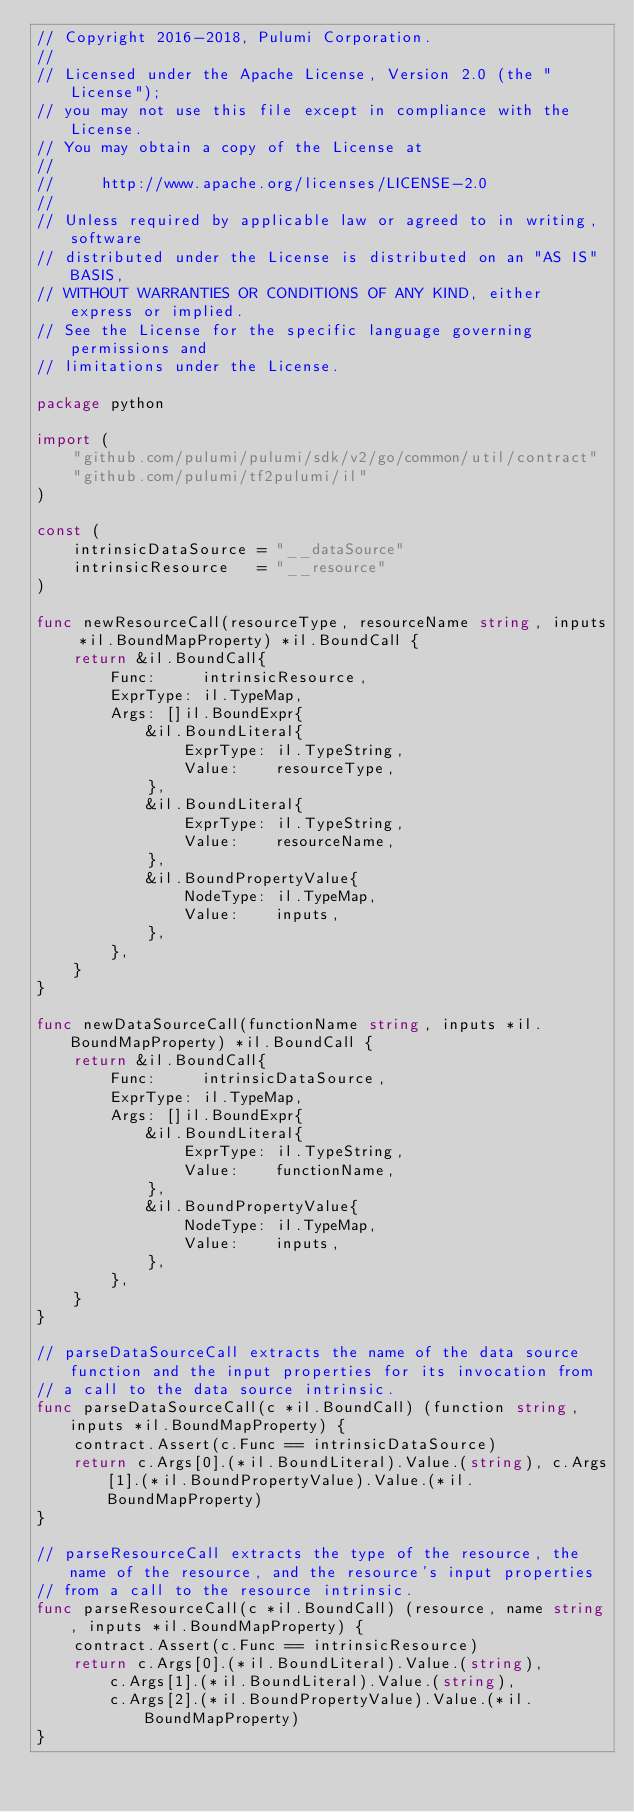Convert code to text. <code><loc_0><loc_0><loc_500><loc_500><_Go_>// Copyright 2016-2018, Pulumi Corporation.
//
// Licensed under the Apache License, Version 2.0 (the "License");
// you may not use this file except in compliance with the License.
// You may obtain a copy of the License at
//
//     http://www.apache.org/licenses/LICENSE-2.0
//
// Unless required by applicable law or agreed to in writing, software
// distributed under the License is distributed on an "AS IS" BASIS,
// WITHOUT WARRANTIES OR CONDITIONS OF ANY KIND, either express or implied.
// See the License for the specific language governing permissions and
// limitations under the License.

package python

import (
	"github.com/pulumi/pulumi/sdk/v2/go/common/util/contract"
	"github.com/pulumi/tf2pulumi/il"
)

const (
	intrinsicDataSource = "__dataSource"
	intrinsicResource   = "__resource"
)

func newResourceCall(resourceType, resourceName string, inputs *il.BoundMapProperty) *il.BoundCall {
	return &il.BoundCall{
		Func:     intrinsicResource,
		ExprType: il.TypeMap,
		Args: []il.BoundExpr{
			&il.BoundLiteral{
				ExprType: il.TypeString,
				Value:    resourceType,
			},
			&il.BoundLiteral{
				ExprType: il.TypeString,
				Value:    resourceName,
			},
			&il.BoundPropertyValue{
				NodeType: il.TypeMap,
				Value:    inputs,
			},
		},
	}
}

func newDataSourceCall(functionName string, inputs *il.BoundMapProperty) *il.BoundCall {
	return &il.BoundCall{
		Func:     intrinsicDataSource,
		ExprType: il.TypeMap,
		Args: []il.BoundExpr{
			&il.BoundLiteral{
				ExprType: il.TypeString,
				Value:    functionName,
			},
			&il.BoundPropertyValue{
				NodeType: il.TypeMap,
				Value:    inputs,
			},
		},
	}
}

// parseDataSourceCall extracts the name of the data source function and the input properties for its invocation from
// a call to the data source intrinsic.
func parseDataSourceCall(c *il.BoundCall) (function string, inputs *il.BoundMapProperty) {
	contract.Assert(c.Func == intrinsicDataSource)
	return c.Args[0].(*il.BoundLiteral).Value.(string), c.Args[1].(*il.BoundPropertyValue).Value.(*il.BoundMapProperty)
}

// parseResourceCall extracts the type of the resource, the name of the resource, and the resource's input properties
// from a call to the resource intrinsic.
func parseResourceCall(c *il.BoundCall) (resource, name string, inputs *il.BoundMapProperty) {
	contract.Assert(c.Func == intrinsicResource)
	return c.Args[0].(*il.BoundLiteral).Value.(string),
		c.Args[1].(*il.BoundLiteral).Value.(string),
		c.Args[2].(*il.BoundPropertyValue).Value.(*il.BoundMapProperty)
}
</code> 